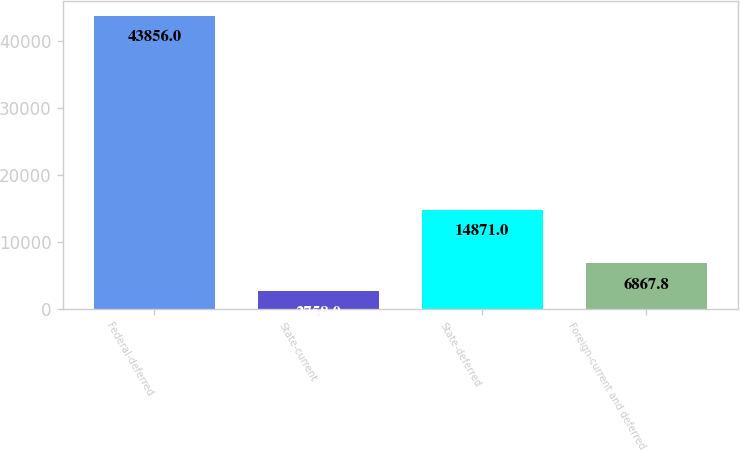Convert chart to OTSL. <chart><loc_0><loc_0><loc_500><loc_500><bar_chart><fcel>Federal-deferred<fcel>State-current<fcel>State-deferred<fcel>Foreign-current and deferred<nl><fcel>43856<fcel>2758<fcel>14871<fcel>6867.8<nl></chart> 